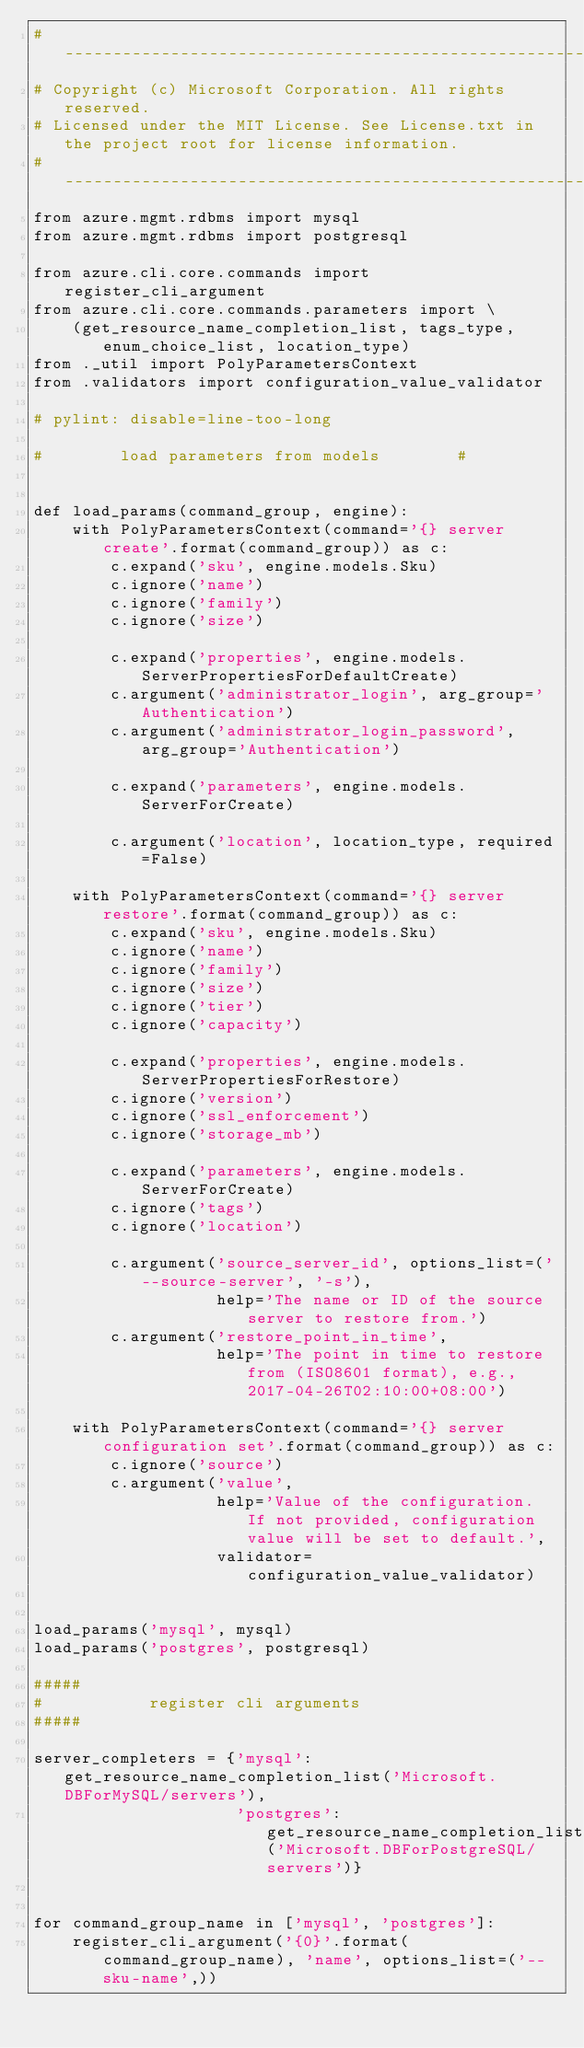<code> <loc_0><loc_0><loc_500><loc_500><_Python_># --------------------------------------------------------------------------------------------
# Copyright (c) Microsoft Corporation. All rights reserved.
# Licensed under the MIT License. See License.txt in the project root for license information.
# --------------------------------------------------------------------------------------------
from azure.mgmt.rdbms import mysql
from azure.mgmt.rdbms import postgresql

from azure.cli.core.commands import register_cli_argument
from azure.cli.core.commands.parameters import \
    (get_resource_name_completion_list, tags_type, enum_choice_list, location_type)
from ._util import PolyParametersContext
from .validators import configuration_value_validator

# pylint: disable=line-too-long

#        load parameters from models        #


def load_params(command_group, engine):
    with PolyParametersContext(command='{} server create'.format(command_group)) as c:
        c.expand('sku', engine.models.Sku)
        c.ignore('name')
        c.ignore('family')
        c.ignore('size')

        c.expand('properties', engine.models.ServerPropertiesForDefaultCreate)
        c.argument('administrator_login', arg_group='Authentication')
        c.argument('administrator_login_password', arg_group='Authentication')

        c.expand('parameters', engine.models.ServerForCreate)

        c.argument('location', location_type, required=False)

    with PolyParametersContext(command='{} server restore'.format(command_group)) as c:
        c.expand('sku', engine.models.Sku)
        c.ignore('name')
        c.ignore('family')
        c.ignore('size')
        c.ignore('tier')
        c.ignore('capacity')

        c.expand('properties', engine.models.ServerPropertiesForRestore)
        c.ignore('version')
        c.ignore('ssl_enforcement')
        c.ignore('storage_mb')

        c.expand('parameters', engine.models.ServerForCreate)
        c.ignore('tags')
        c.ignore('location')

        c.argument('source_server_id', options_list=('--source-server', '-s'),
                   help='The name or ID of the source server to restore from.')
        c.argument('restore_point_in_time',
                   help='The point in time to restore from (ISO8601 format), e.g., 2017-04-26T02:10:00+08:00')

    with PolyParametersContext(command='{} server configuration set'.format(command_group)) as c:
        c.ignore('source')
        c.argument('value',
                   help='Value of the configuration. If not provided, configuration value will be set to default.',
                   validator=configuration_value_validator)


load_params('mysql', mysql)
load_params('postgres', postgresql)

#####
#           register cli arguments
#####

server_completers = {'mysql': get_resource_name_completion_list('Microsoft.DBForMySQL/servers'),
                     'postgres': get_resource_name_completion_list('Microsoft.DBForPostgreSQL/servers')}


for command_group_name in ['mysql', 'postgres']:
    register_cli_argument('{0}'.format(command_group_name), 'name', options_list=('--sku-name',))</code> 